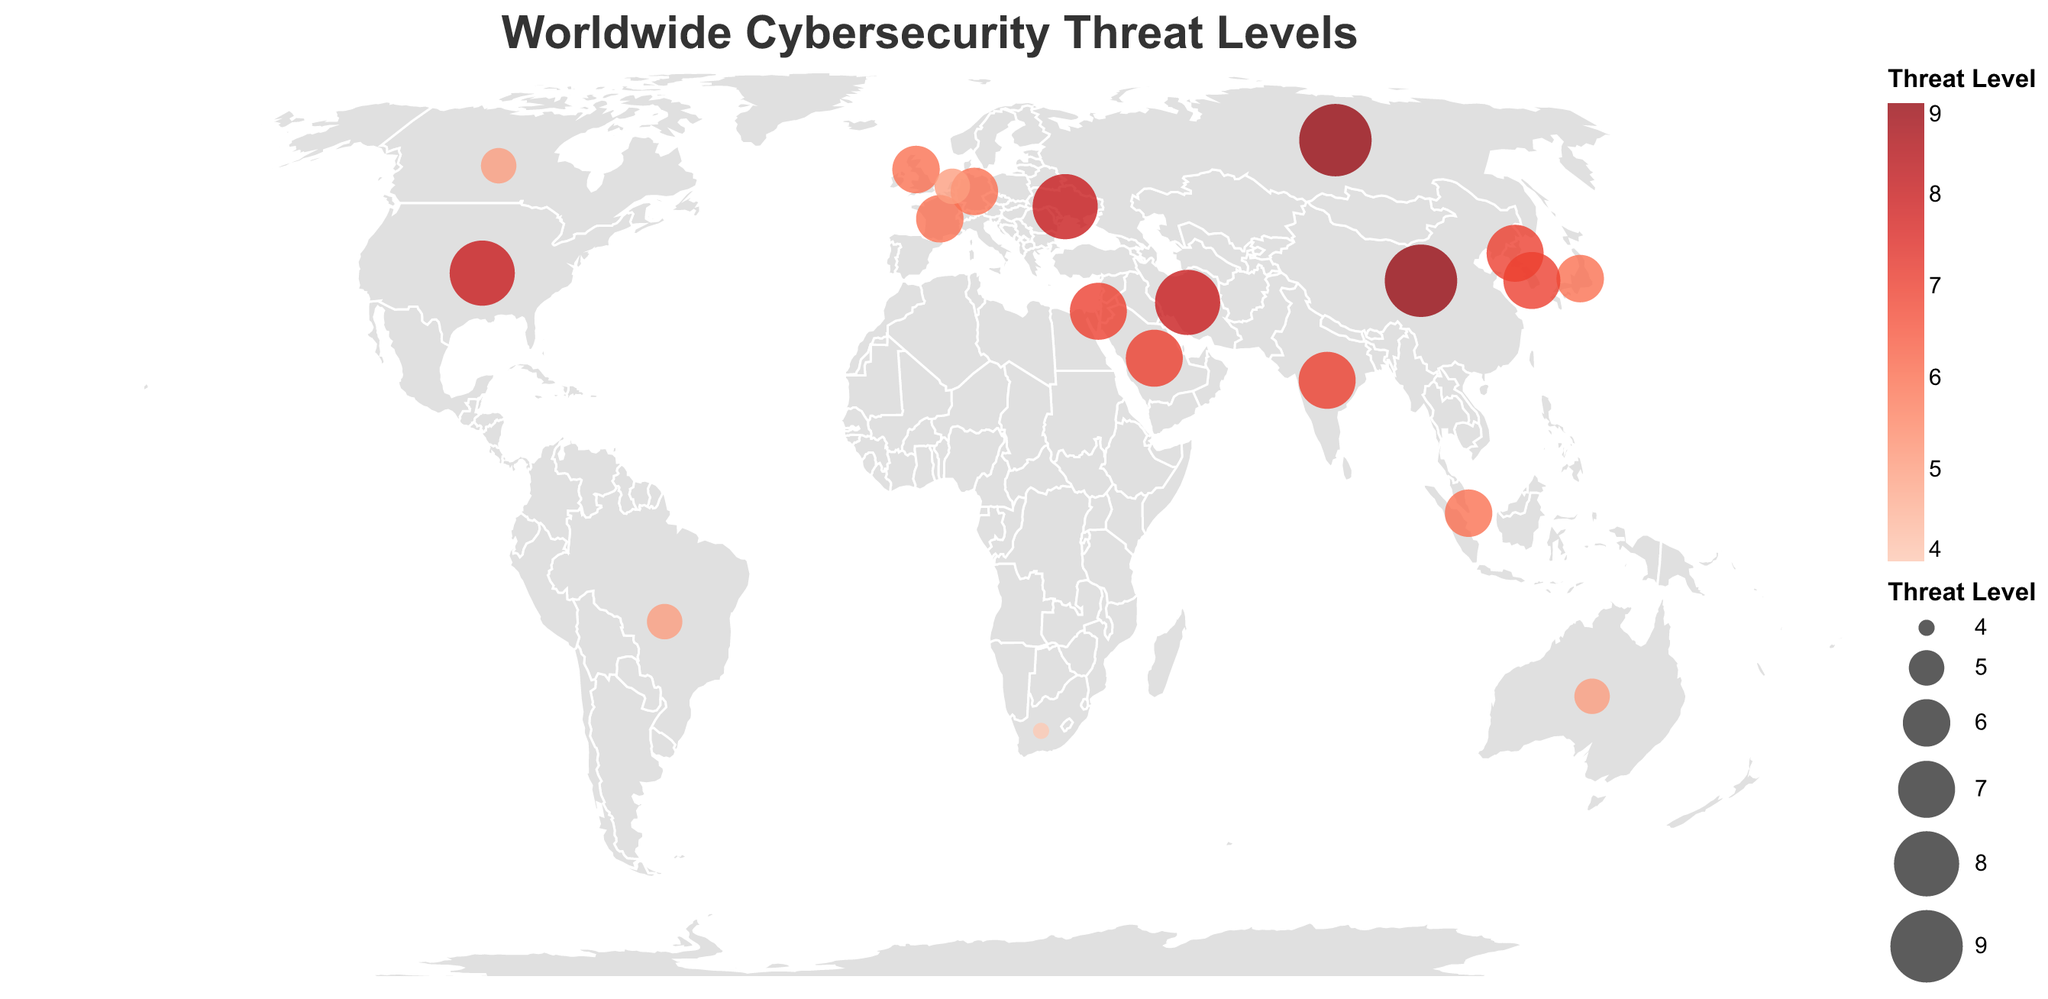What country has the highest cybersecurity threat level? The highest threat level is represented by the largest circle and the deepest red color. By examining the plot, we find that China and Russia both have the highest level, which is 9.
Answer: China and Russia What hotspot type is associated with North Korea? Locate North Korea on the plot and hover over the circle to reveal the tooltip that shows the hotspot type. North Korea's hotspot type is "Cryptocurrency theft".
Answer: Cryptocurrency theft Between United States and Canada, which country has a higher threat level? Compare the size of the circles and the color intensity for both countries. The United States has a larger circle and a deeper red color compared to Canada, indicating a higher threat level.
Answer: United States How many countries have a threat level equal to or greater than 8? Count the circles with a size and color intensity corresponding to a threat level of 8 or 9. These countries are the United States, China, Russia, Iran, and Ukraine.
Answer: 5 What is the average threat level of countries with hotspots related to the financial sector? Identify the countries with financial sector-related hotspots (United Kingdom and Singapore) and their threat levels (both 6). Calculate the average: (6 + 6) / 2 = 6.
Answer: 6 Which country targets critical infrastructure, and what is its threat level? Look for the tooltip information showing "Critical infrastructure targeting". This information points to Iran, which has a threat level of 8.
Answer: Iran, 8 What color is used to represent the lowest threat level on the map? The map uses a color gradient to represent threat levels. The country with the lowest threat level is South Africa (threat level 4), which is represented by a lighter red or pink color.
Answer: Light red/pink Compare the threat levels of Germany and Japan. Which country has a higher level? Locate both Germany and Japan on the map and compare their circle sizes and color intensities. Both countries have similar sizes and colors, indicating they both have the same threat level.
Answer: Equal What is the most common hotspot type among countries with a threat level of 7? Identify the countries with a threat level of 7 and list their hotspot types: North Korea (Cryptocurrency theft), Israel (Defense sector breaches), India (Ransomware campaigns), South Korea (Advanced persistent threats), Saudi Arabia (Energy sector targeting). No single hotspot type repeats itself, so all listed types are equally common.
Answer: No most common type Which two countries have a cyber threat related to the energy sector, and what are their threat levels? Locate the countries with tooltip information indicating energy sector targeting: Saudi Arabia (7) and another country is absent, thus it's only Saudi Arabia.
Answer: Saudi Arabia, 7 